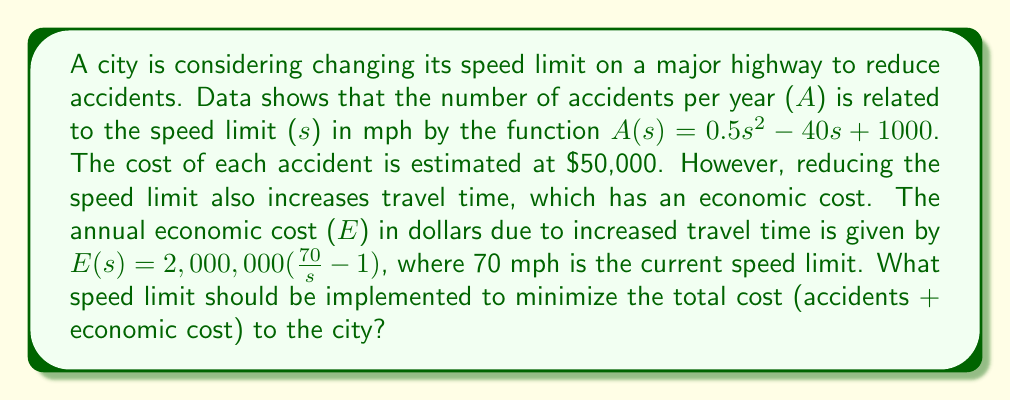Could you help me with this problem? 1) First, let's define the total cost function C(s):
   $C(s) = 50,000A(s) + E(s)$

2) Substitute the given functions:
   $C(s) = 50,000(0.5s^2 - 40s + 1000) + 2,000,000(\frac{70}{s} - 1)$

3) Simplify:
   $C(s) = 25,000s^2 - 2,000,000s + 50,000,000 + \frac{140,000,000}{s} - 2,000,000$
   $C(s) = 25,000s^2 - 2,000,000s + 48,000,000 + \frac{140,000,000}{s}$

4) To find the minimum, differentiate C(s) with respect to s and set it to zero:
   $\frac{dC}{ds} = 50,000s - 2,000,000 - \frac{140,000,000}{s^2} = 0$

5) Multiply both sides by $s^2$:
   $50,000s^3 - 2,000,000s^2 - 140,000,000 = 0$

6) This is a cubic equation. It can be solved numerically or by using the cubic formula. Using a numerical method or calculator, we find that the relevant solution (between 0 and 70) is approximately:
   $s \approx 53.8$ mph

7) To confirm this is a minimum, we can check the second derivative is positive at this point.
Answer: 53.8 mph 